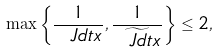<formula> <loc_0><loc_0><loc_500><loc_500>\max \left \{ \frac { 1 } { \ J d t x } , \frac { 1 } { \widetilde { \ J d t x } } \right \} \leq 2 ,</formula> 